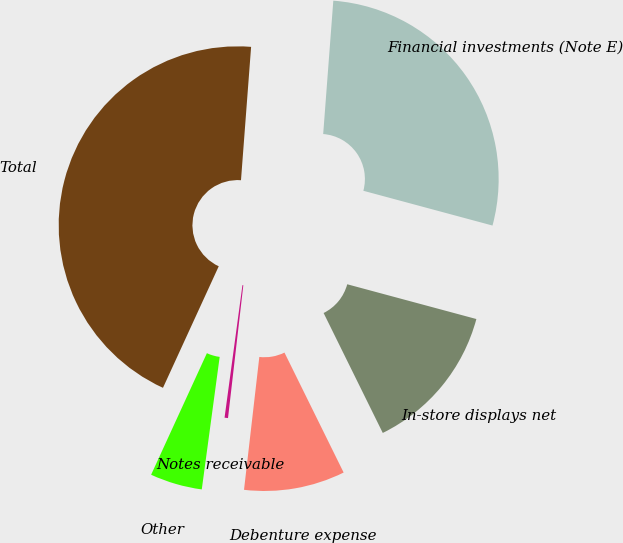<chart> <loc_0><loc_0><loc_500><loc_500><pie_chart><fcel>Financial investments (Note E)<fcel>In-store displays net<fcel>Debenture expense<fcel>Notes receivable<fcel>Other<fcel>Total<nl><fcel>27.98%<fcel>13.52%<fcel>9.12%<fcel>0.31%<fcel>4.71%<fcel>44.36%<nl></chart> 